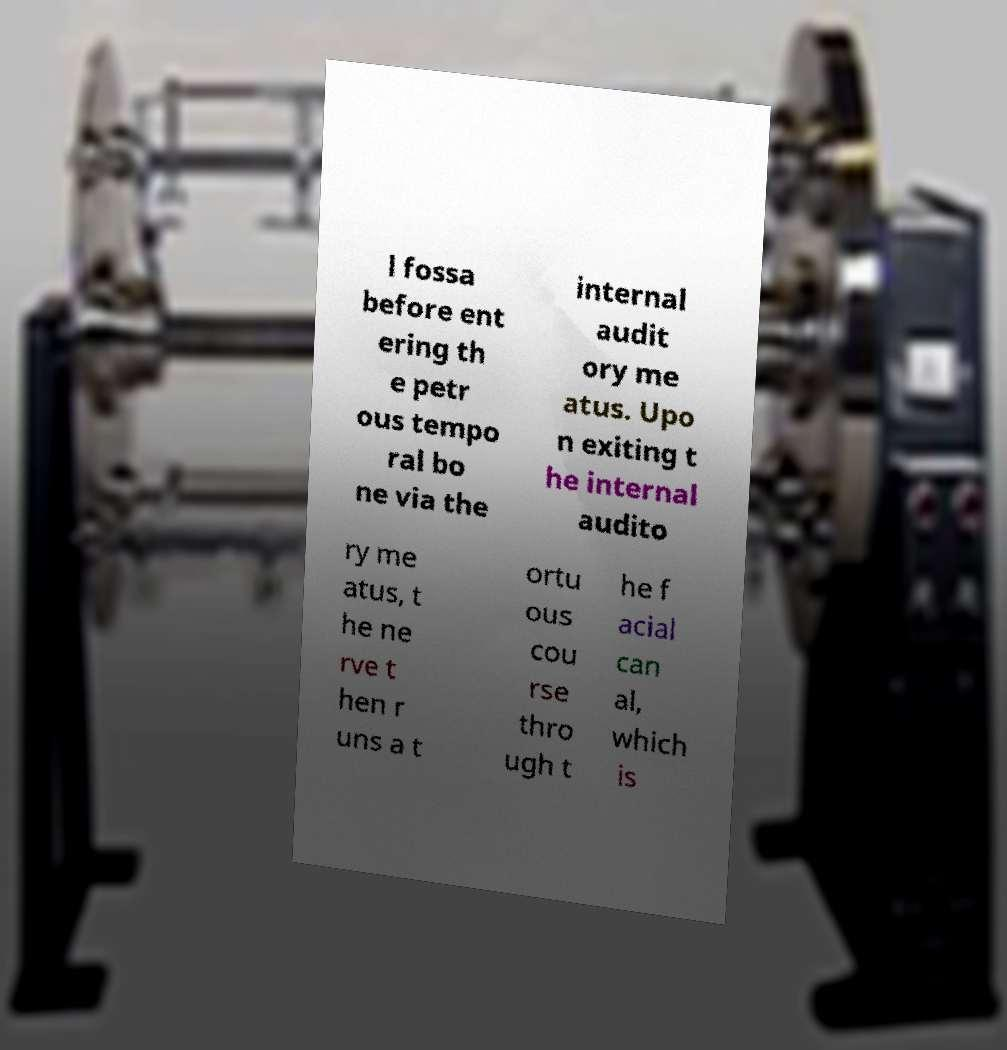I need the written content from this picture converted into text. Can you do that? l fossa before ent ering th e petr ous tempo ral bo ne via the internal audit ory me atus. Upo n exiting t he internal audito ry me atus, t he ne rve t hen r uns a t ortu ous cou rse thro ugh t he f acial can al, which is 